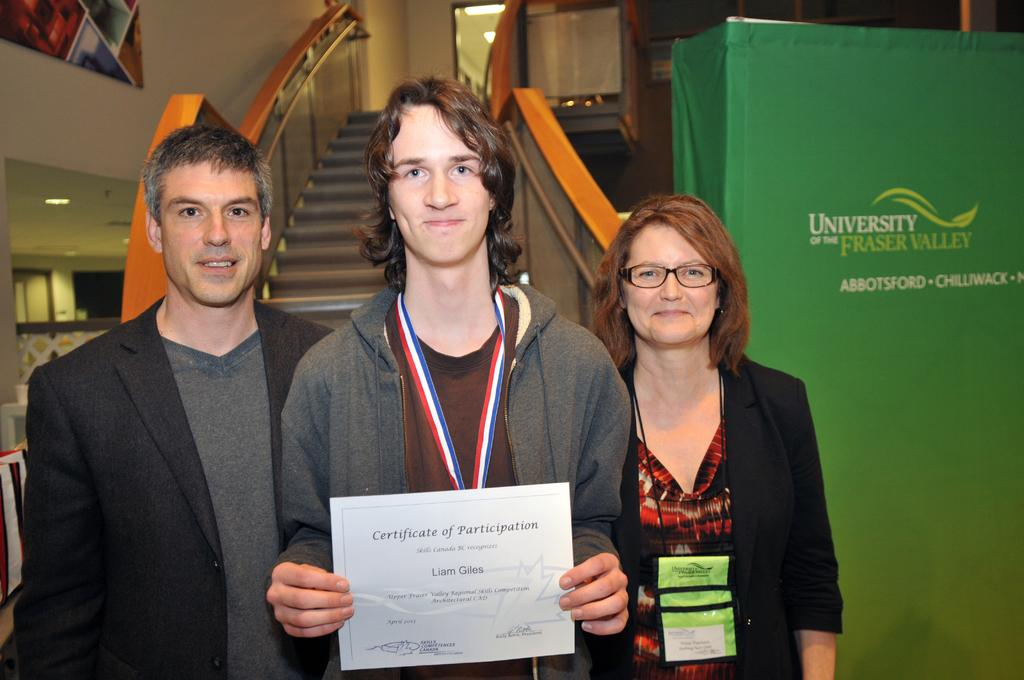<image>
Present a compact description of the photo's key features. A man standing with two people next to a sign that says University of the Fraser Valley. 